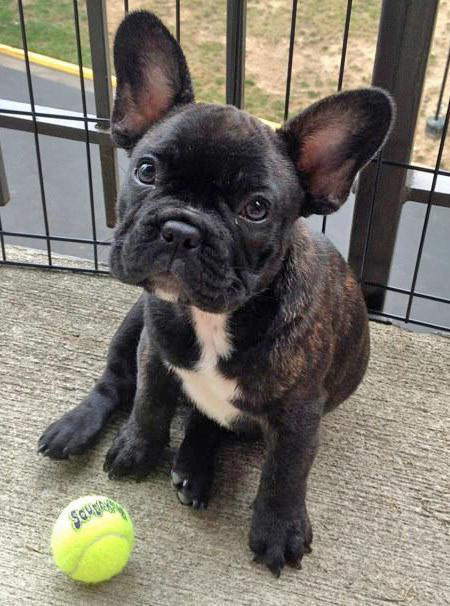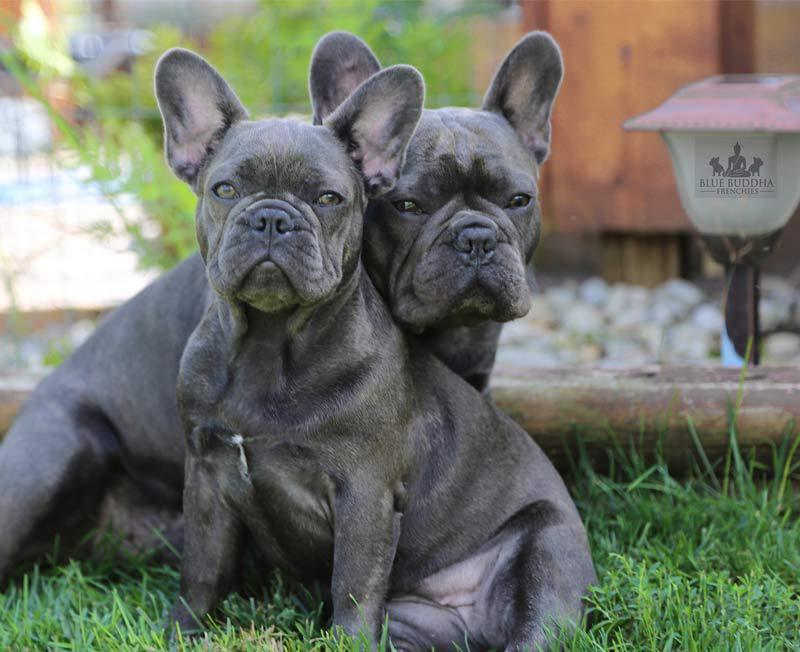The first image is the image on the left, the second image is the image on the right. For the images displayed, is the sentence "There are three dogs" factually correct? Answer yes or no. Yes. The first image is the image on the left, the second image is the image on the right. Considering the images on both sides, is "One image features exactly two dogs posed close together and facing  forward." valid? Answer yes or no. Yes. 